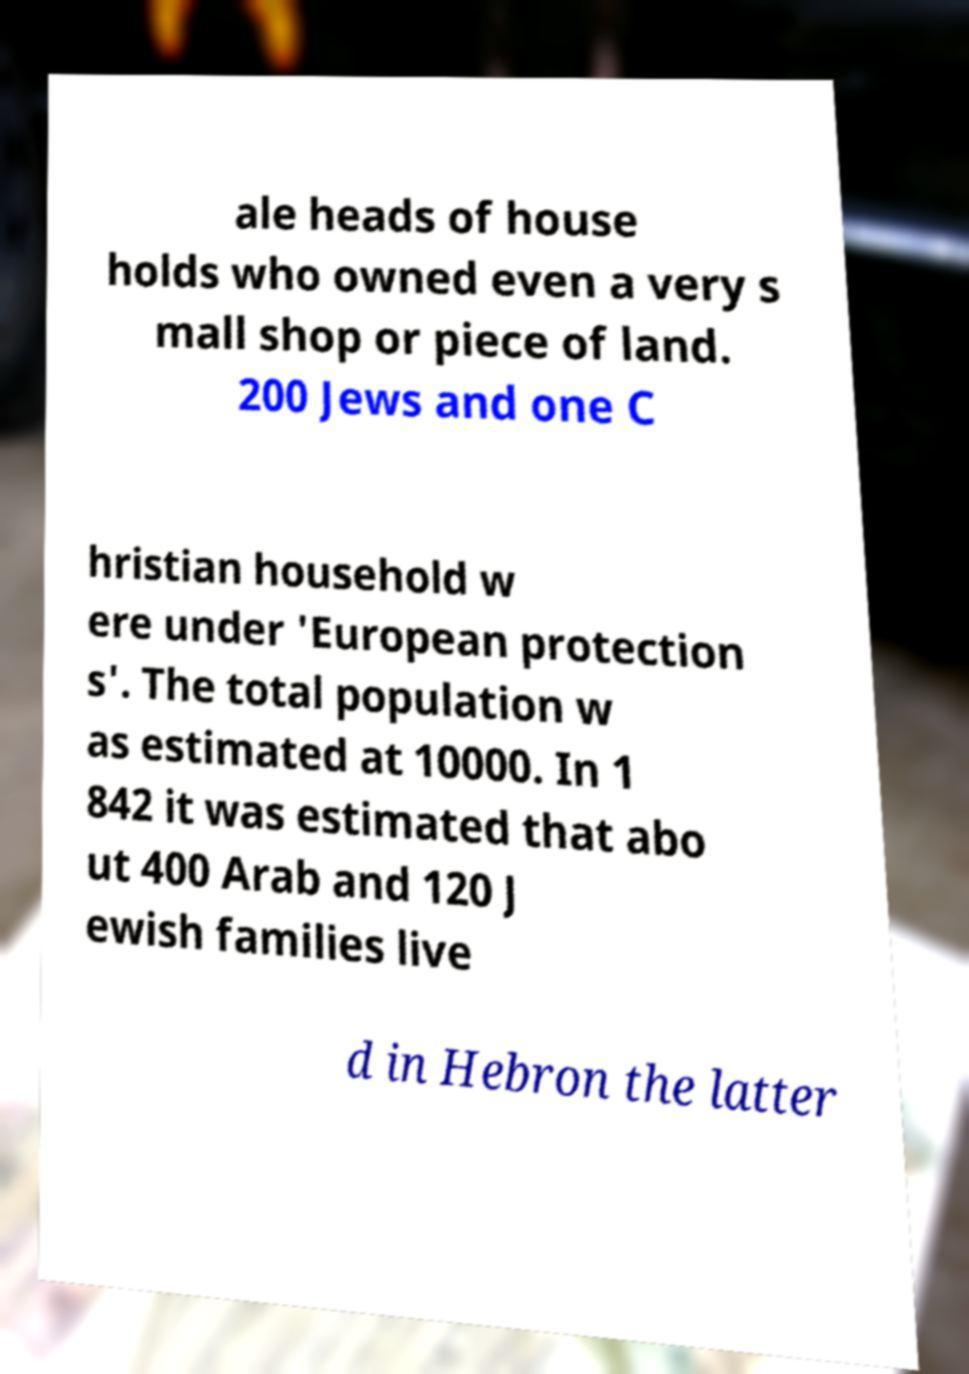There's text embedded in this image that I need extracted. Can you transcribe it verbatim? ale heads of house holds who owned even a very s mall shop or piece of land. 200 Jews and one C hristian household w ere under 'European protection s'. The total population w as estimated at 10000. In 1 842 it was estimated that abo ut 400 Arab and 120 J ewish families live d in Hebron the latter 